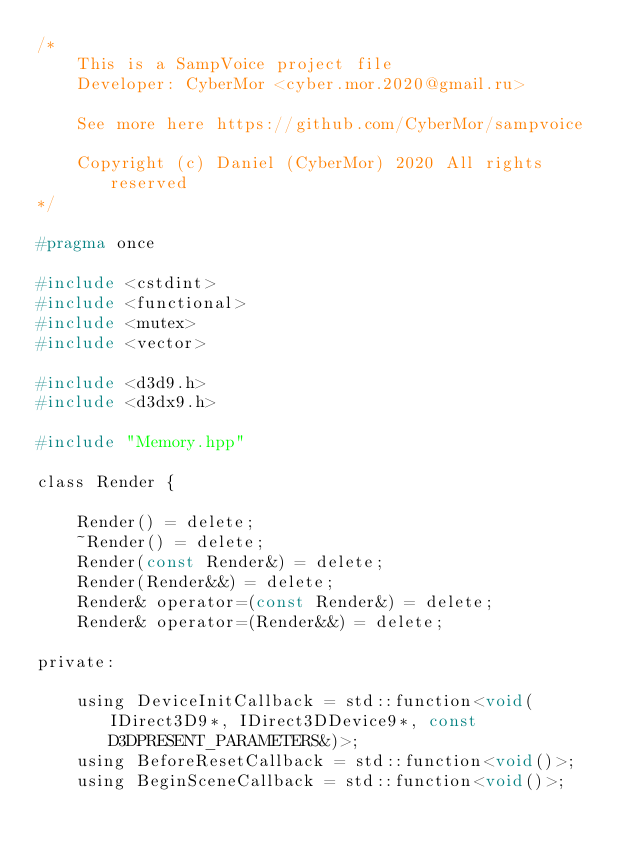Convert code to text. <code><loc_0><loc_0><loc_500><loc_500><_C_>/*
    This is a SampVoice project file
    Developer: CyberMor <cyber.mor.2020@gmail.ru>

    See more here https://github.com/CyberMor/sampvoice

    Copyright (c) Daniel (CyberMor) 2020 All rights reserved
*/

#pragma once

#include <cstdint>
#include <functional>
#include <mutex>
#include <vector>

#include <d3d9.h>
#include <d3dx9.h>

#include "Memory.hpp"

class Render {

    Render() = delete;
    ~Render() = delete;
    Render(const Render&) = delete;
    Render(Render&&) = delete;
    Render& operator=(const Render&) = delete;
    Render& operator=(Render&&) = delete;

private:

    using DeviceInitCallback = std::function<void(IDirect3D9*, IDirect3DDevice9*, const D3DPRESENT_PARAMETERS&)>;
    using BeforeResetCallback = std::function<void()>;
    using BeginSceneCallback = std::function<void()>;</code> 